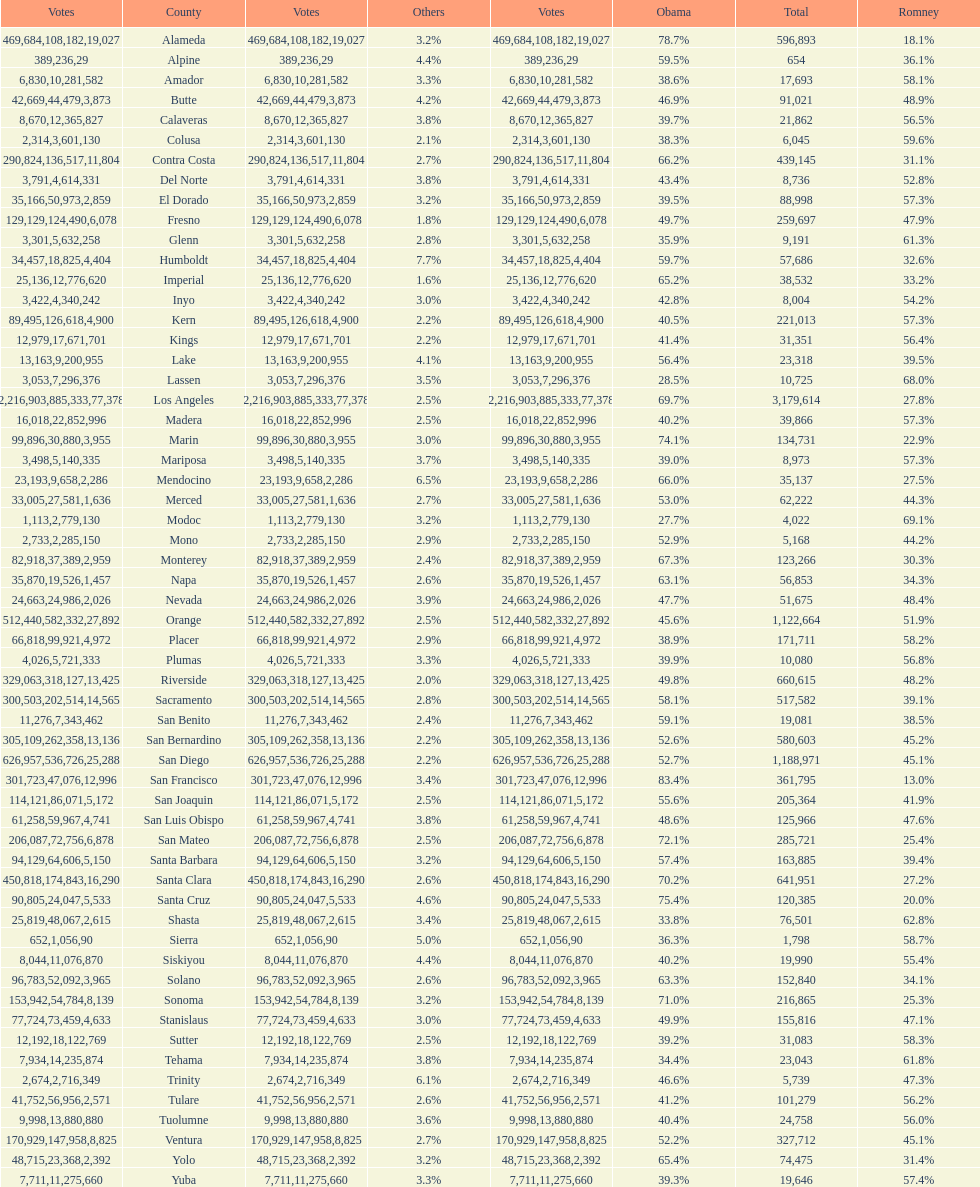Which county had the most total votes? Los Angeles. 